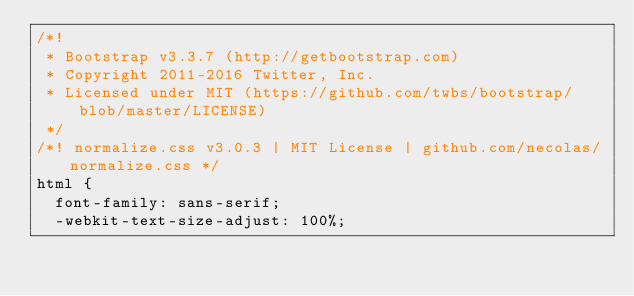<code> <loc_0><loc_0><loc_500><loc_500><_CSS_>/*!
 * Bootstrap v3.3.7 (http://getbootstrap.com)
 * Copyright 2011-2016 Twitter, Inc.
 * Licensed under MIT (https://github.com/twbs/bootstrap/blob/master/LICENSE)
 */
/*! normalize.css v3.0.3 | MIT License | github.com/necolas/normalize.css */
html {
  font-family: sans-serif;
  -webkit-text-size-adjust: 100%;</code> 